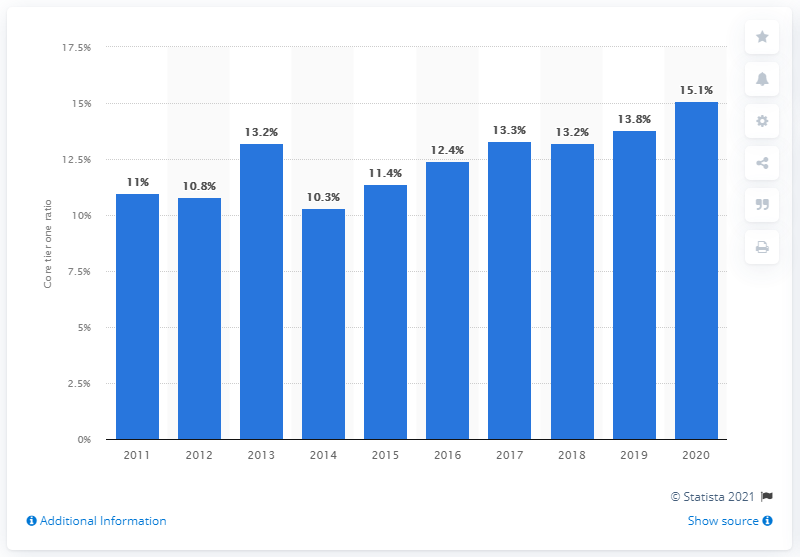Highlight a few significant elements in this photo. The CET1 ratio for Barclays in 2020 was 15.1. 